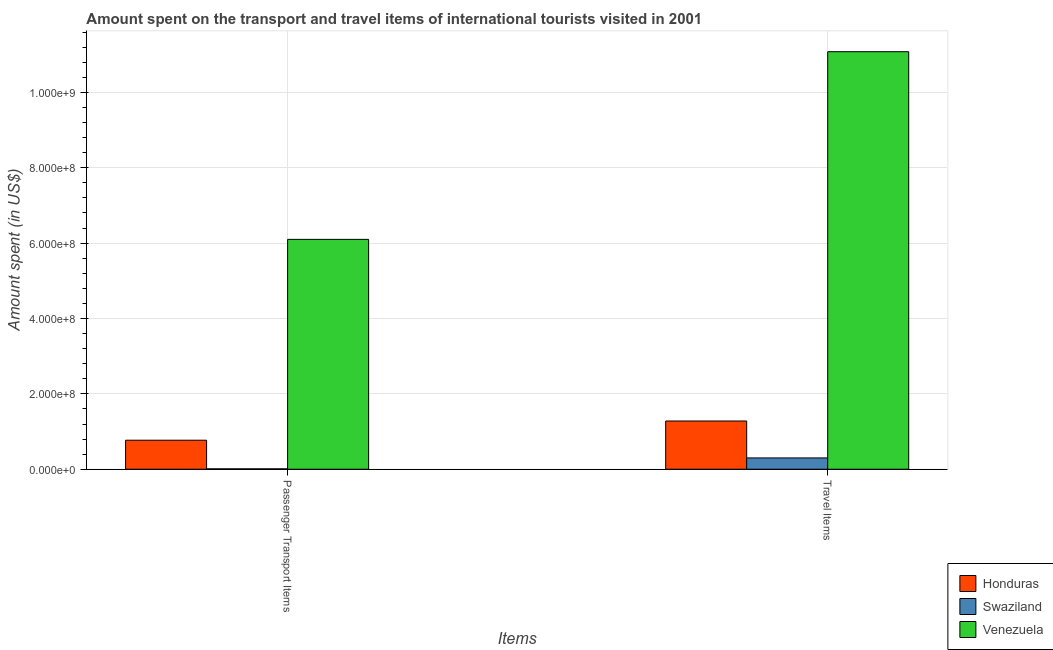How many different coloured bars are there?
Provide a short and direct response. 3. Are the number of bars per tick equal to the number of legend labels?
Make the answer very short. Yes. What is the label of the 1st group of bars from the left?
Provide a succinct answer. Passenger Transport Items. What is the amount spent on passenger transport items in Venezuela?
Keep it short and to the point. 6.10e+08. Across all countries, what is the maximum amount spent on passenger transport items?
Give a very brief answer. 6.10e+08. Across all countries, what is the minimum amount spent in travel items?
Your answer should be very brief. 3.00e+07. In which country was the amount spent in travel items maximum?
Your answer should be very brief. Venezuela. In which country was the amount spent in travel items minimum?
Keep it short and to the point. Swaziland. What is the total amount spent in travel items in the graph?
Your answer should be compact. 1.27e+09. What is the difference between the amount spent on passenger transport items in Swaziland and that in Venezuela?
Ensure brevity in your answer.  -6.09e+08. What is the difference between the amount spent on passenger transport items in Honduras and the amount spent in travel items in Venezuela?
Offer a terse response. -1.03e+09. What is the average amount spent on passenger transport items per country?
Your response must be concise. 2.29e+08. What is the difference between the amount spent on passenger transport items and amount spent in travel items in Honduras?
Your answer should be compact. -5.10e+07. In how many countries, is the amount spent on passenger transport items greater than 240000000 US$?
Your answer should be compact. 1. What is the ratio of the amount spent on passenger transport items in Swaziland to that in Venezuela?
Provide a succinct answer. 0. In how many countries, is the amount spent on passenger transport items greater than the average amount spent on passenger transport items taken over all countries?
Provide a short and direct response. 1. What does the 2nd bar from the left in Travel Items represents?
Ensure brevity in your answer.  Swaziland. What does the 1st bar from the right in Travel Items represents?
Offer a terse response. Venezuela. How many countries are there in the graph?
Offer a terse response. 3. Does the graph contain any zero values?
Keep it short and to the point. No. Does the graph contain grids?
Your answer should be compact. Yes. What is the title of the graph?
Keep it short and to the point. Amount spent on the transport and travel items of international tourists visited in 2001. Does "Bangladesh" appear as one of the legend labels in the graph?
Keep it short and to the point. No. What is the label or title of the X-axis?
Your answer should be very brief. Items. What is the label or title of the Y-axis?
Offer a very short reply. Amount spent (in US$). What is the Amount spent (in US$) in Honduras in Passenger Transport Items?
Ensure brevity in your answer.  7.70e+07. What is the Amount spent (in US$) in Venezuela in Passenger Transport Items?
Your answer should be compact. 6.10e+08. What is the Amount spent (in US$) of Honduras in Travel Items?
Your response must be concise. 1.28e+08. What is the Amount spent (in US$) in Swaziland in Travel Items?
Offer a terse response. 3.00e+07. What is the Amount spent (in US$) of Venezuela in Travel Items?
Provide a succinct answer. 1.11e+09. Across all Items, what is the maximum Amount spent (in US$) in Honduras?
Provide a succinct answer. 1.28e+08. Across all Items, what is the maximum Amount spent (in US$) in Swaziland?
Give a very brief answer. 3.00e+07. Across all Items, what is the maximum Amount spent (in US$) of Venezuela?
Offer a very short reply. 1.11e+09. Across all Items, what is the minimum Amount spent (in US$) of Honduras?
Provide a short and direct response. 7.70e+07. Across all Items, what is the minimum Amount spent (in US$) of Venezuela?
Make the answer very short. 6.10e+08. What is the total Amount spent (in US$) of Honduras in the graph?
Give a very brief answer. 2.05e+08. What is the total Amount spent (in US$) of Swaziland in the graph?
Make the answer very short. 3.10e+07. What is the total Amount spent (in US$) in Venezuela in the graph?
Offer a terse response. 1.72e+09. What is the difference between the Amount spent (in US$) in Honduras in Passenger Transport Items and that in Travel Items?
Your answer should be compact. -5.10e+07. What is the difference between the Amount spent (in US$) of Swaziland in Passenger Transport Items and that in Travel Items?
Your answer should be compact. -2.90e+07. What is the difference between the Amount spent (in US$) of Venezuela in Passenger Transport Items and that in Travel Items?
Give a very brief answer. -4.98e+08. What is the difference between the Amount spent (in US$) in Honduras in Passenger Transport Items and the Amount spent (in US$) in Swaziland in Travel Items?
Your answer should be very brief. 4.70e+07. What is the difference between the Amount spent (in US$) of Honduras in Passenger Transport Items and the Amount spent (in US$) of Venezuela in Travel Items?
Provide a succinct answer. -1.03e+09. What is the difference between the Amount spent (in US$) of Swaziland in Passenger Transport Items and the Amount spent (in US$) of Venezuela in Travel Items?
Your answer should be compact. -1.11e+09. What is the average Amount spent (in US$) in Honduras per Items?
Offer a very short reply. 1.02e+08. What is the average Amount spent (in US$) in Swaziland per Items?
Your answer should be very brief. 1.55e+07. What is the average Amount spent (in US$) of Venezuela per Items?
Ensure brevity in your answer.  8.59e+08. What is the difference between the Amount spent (in US$) of Honduras and Amount spent (in US$) of Swaziland in Passenger Transport Items?
Your response must be concise. 7.60e+07. What is the difference between the Amount spent (in US$) of Honduras and Amount spent (in US$) of Venezuela in Passenger Transport Items?
Offer a very short reply. -5.33e+08. What is the difference between the Amount spent (in US$) in Swaziland and Amount spent (in US$) in Venezuela in Passenger Transport Items?
Your answer should be compact. -6.09e+08. What is the difference between the Amount spent (in US$) in Honduras and Amount spent (in US$) in Swaziland in Travel Items?
Give a very brief answer. 9.80e+07. What is the difference between the Amount spent (in US$) of Honduras and Amount spent (in US$) of Venezuela in Travel Items?
Keep it short and to the point. -9.80e+08. What is the difference between the Amount spent (in US$) of Swaziland and Amount spent (in US$) of Venezuela in Travel Items?
Your answer should be very brief. -1.08e+09. What is the ratio of the Amount spent (in US$) of Honduras in Passenger Transport Items to that in Travel Items?
Provide a succinct answer. 0.6. What is the ratio of the Amount spent (in US$) of Swaziland in Passenger Transport Items to that in Travel Items?
Make the answer very short. 0.03. What is the ratio of the Amount spent (in US$) of Venezuela in Passenger Transport Items to that in Travel Items?
Keep it short and to the point. 0.55. What is the difference between the highest and the second highest Amount spent (in US$) in Honduras?
Your response must be concise. 5.10e+07. What is the difference between the highest and the second highest Amount spent (in US$) in Swaziland?
Give a very brief answer. 2.90e+07. What is the difference between the highest and the second highest Amount spent (in US$) of Venezuela?
Provide a short and direct response. 4.98e+08. What is the difference between the highest and the lowest Amount spent (in US$) of Honduras?
Offer a very short reply. 5.10e+07. What is the difference between the highest and the lowest Amount spent (in US$) in Swaziland?
Make the answer very short. 2.90e+07. What is the difference between the highest and the lowest Amount spent (in US$) in Venezuela?
Make the answer very short. 4.98e+08. 